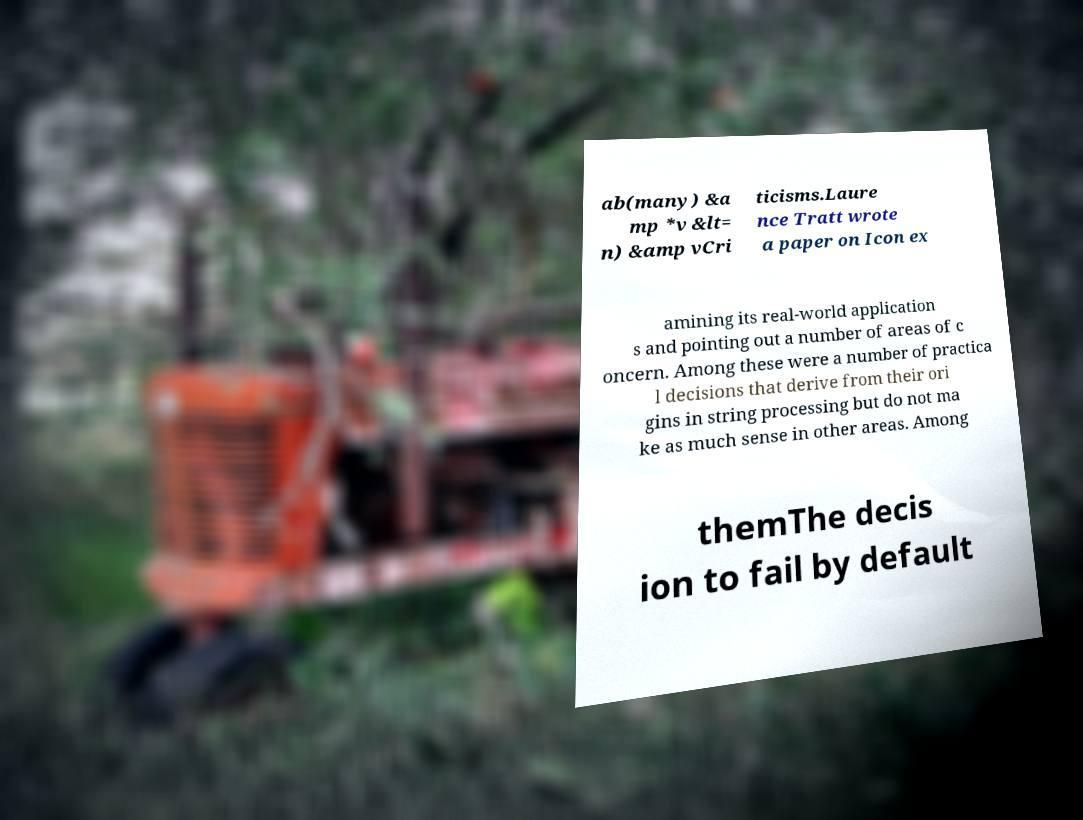Could you extract and type out the text from this image? ab(many) &a mp *v &lt= n) &amp vCri ticisms.Laure nce Tratt wrote a paper on Icon ex amining its real-world application s and pointing out a number of areas of c oncern. Among these were a number of practica l decisions that derive from their ori gins in string processing but do not ma ke as much sense in other areas. Among themThe decis ion to fail by default 